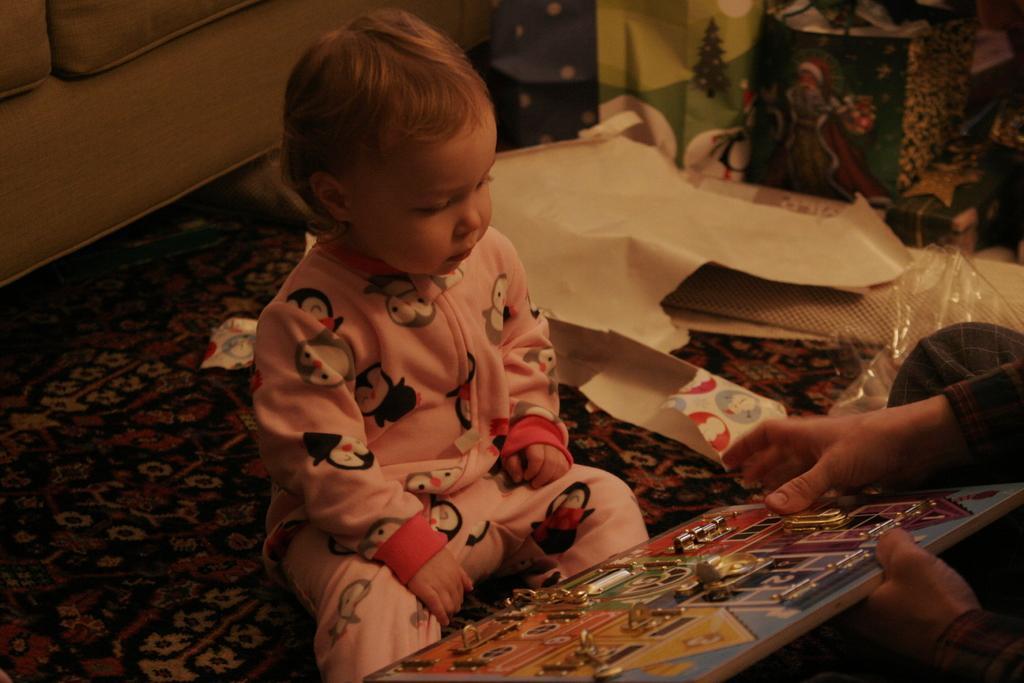Can you describe this image briefly? In this image we can see a kid. On the right we can see a person holding an object. In the background there is a sofa and we can see bags. At the bottom there is a carpet. 